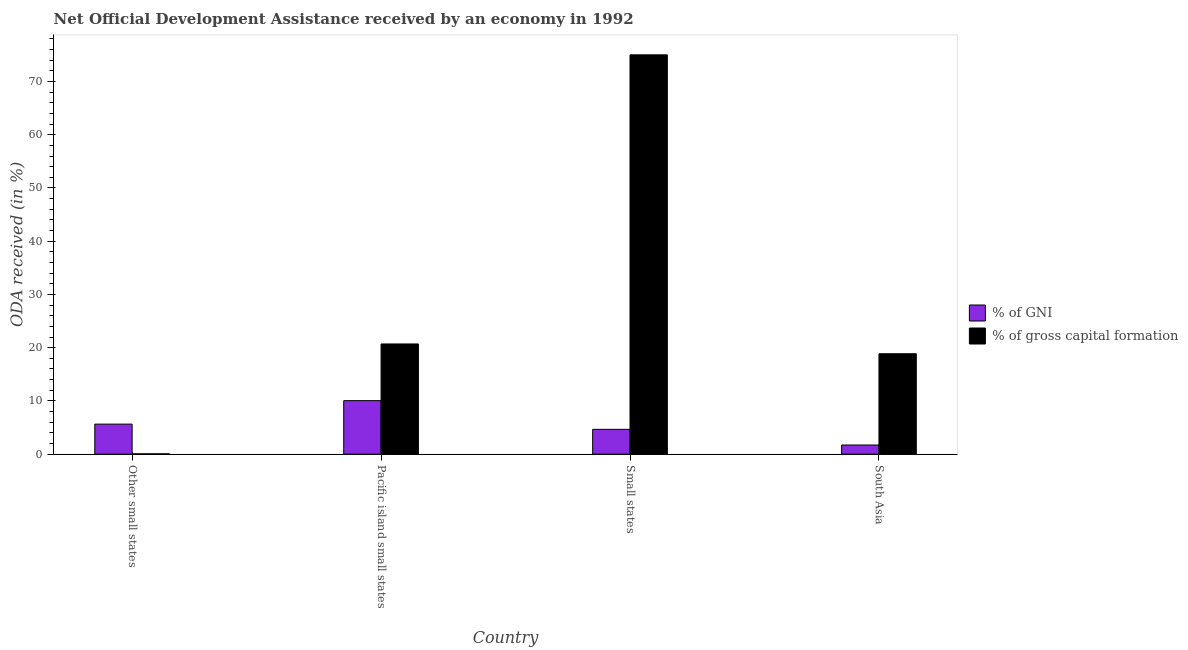How many different coloured bars are there?
Ensure brevity in your answer.  2. How many groups of bars are there?
Offer a terse response. 4. Are the number of bars per tick equal to the number of legend labels?
Keep it short and to the point. Yes. How many bars are there on the 2nd tick from the right?
Your response must be concise. 2. What is the label of the 3rd group of bars from the left?
Provide a succinct answer. Small states. In how many cases, is the number of bars for a given country not equal to the number of legend labels?
Offer a terse response. 0. What is the oda received as percentage of gross capital formation in Small states?
Give a very brief answer. 75. Across all countries, what is the maximum oda received as percentage of gross capital formation?
Offer a very short reply. 75. Across all countries, what is the minimum oda received as percentage of gni?
Give a very brief answer. 1.72. In which country was the oda received as percentage of gross capital formation maximum?
Your response must be concise. Small states. In which country was the oda received as percentage of gni minimum?
Give a very brief answer. South Asia. What is the total oda received as percentage of gross capital formation in the graph?
Give a very brief answer. 114.62. What is the difference between the oda received as percentage of gross capital formation in Other small states and that in Small states?
Give a very brief answer. -74.94. What is the difference between the oda received as percentage of gross capital formation in Small states and the oda received as percentage of gni in Other small states?
Provide a short and direct response. 69.36. What is the average oda received as percentage of gross capital formation per country?
Offer a very short reply. 28.65. What is the difference between the oda received as percentage of gross capital formation and oda received as percentage of gni in South Asia?
Your answer should be very brief. 17.14. What is the ratio of the oda received as percentage of gni in Pacific island small states to that in Small states?
Offer a very short reply. 2.16. Is the oda received as percentage of gni in Other small states less than that in Pacific island small states?
Provide a short and direct response. Yes. Is the difference between the oda received as percentage of gross capital formation in Pacific island small states and South Asia greater than the difference between the oda received as percentage of gni in Pacific island small states and South Asia?
Provide a succinct answer. No. What is the difference between the highest and the second highest oda received as percentage of gni?
Provide a succinct answer. 4.41. What is the difference between the highest and the lowest oda received as percentage of gross capital formation?
Provide a succinct answer. 74.94. In how many countries, is the oda received as percentage of gross capital formation greater than the average oda received as percentage of gross capital formation taken over all countries?
Offer a very short reply. 1. What does the 2nd bar from the left in Pacific island small states represents?
Your answer should be compact. % of gross capital formation. What does the 1st bar from the right in Other small states represents?
Provide a short and direct response. % of gross capital formation. How many countries are there in the graph?
Your response must be concise. 4. What is the title of the graph?
Your response must be concise. Net Official Development Assistance received by an economy in 1992. What is the label or title of the X-axis?
Keep it short and to the point. Country. What is the label or title of the Y-axis?
Your answer should be compact. ODA received (in %). What is the ODA received (in %) of % of GNI in Other small states?
Keep it short and to the point. 5.64. What is the ODA received (in %) of % of gross capital formation in Other small states?
Keep it short and to the point. 0.06. What is the ODA received (in %) of % of GNI in Pacific island small states?
Provide a short and direct response. 10.05. What is the ODA received (in %) of % of gross capital formation in Pacific island small states?
Your answer should be very brief. 20.7. What is the ODA received (in %) of % of GNI in Small states?
Provide a short and direct response. 4.66. What is the ODA received (in %) in % of gross capital formation in Small states?
Your answer should be compact. 75. What is the ODA received (in %) in % of GNI in South Asia?
Your response must be concise. 1.72. What is the ODA received (in %) in % of gross capital formation in South Asia?
Keep it short and to the point. 18.86. Across all countries, what is the maximum ODA received (in %) of % of GNI?
Make the answer very short. 10.05. Across all countries, what is the maximum ODA received (in %) of % of gross capital formation?
Give a very brief answer. 75. Across all countries, what is the minimum ODA received (in %) of % of GNI?
Your answer should be compact. 1.72. Across all countries, what is the minimum ODA received (in %) of % of gross capital formation?
Your answer should be compact. 0.06. What is the total ODA received (in %) of % of GNI in the graph?
Your response must be concise. 22.08. What is the total ODA received (in %) of % of gross capital formation in the graph?
Ensure brevity in your answer.  114.62. What is the difference between the ODA received (in %) of % of GNI in Other small states and that in Pacific island small states?
Make the answer very short. -4.41. What is the difference between the ODA received (in %) in % of gross capital formation in Other small states and that in Pacific island small states?
Keep it short and to the point. -20.64. What is the difference between the ODA received (in %) in % of GNI in Other small states and that in Small states?
Your answer should be very brief. 0.98. What is the difference between the ODA received (in %) of % of gross capital formation in Other small states and that in Small states?
Provide a succinct answer. -74.94. What is the difference between the ODA received (in %) in % of GNI in Other small states and that in South Asia?
Offer a very short reply. 3.92. What is the difference between the ODA received (in %) of % of gross capital formation in Other small states and that in South Asia?
Provide a short and direct response. -18.8. What is the difference between the ODA received (in %) in % of GNI in Pacific island small states and that in Small states?
Keep it short and to the point. 5.39. What is the difference between the ODA received (in %) of % of gross capital formation in Pacific island small states and that in Small states?
Your answer should be compact. -54.3. What is the difference between the ODA received (in %) in % of GNI in Pacific island small states and that in South Asia?
Ensure brevity in your answer.  8.33. What is the difference between the ODA received (in %) in % of gross capital formation in Pacific island small states and that in South Asia?
Your response must be concise. 1.83. What is the difference between the ODA received (in %) of % of GNI in Small states and that in South Asia?
Provide a succinct answer. 2.94. What is the difference between the ODA received (in %) in % of gross capital formation in Small states and that in South Asia?
Your answer should be very brief. 56.14. What is the difference between the ODA received (in %) of % of GNI in Other small states and the ODA received (in %) of % of gross capital formation in Pacific island small states?
Your response must be concise. -15.05. What is the difference between the ODA received (in %) of % of GNI in Other small states and the ODA received (in %) of % of gross capital formation in Small states?
Give a very brief answer. -69.36. What is the difference between the ODA received (in %) in % of GNI in Other small states and the ODA received (in %) in % of gross capital formation in South Asia?
Offer a very short reply. -13.22. What is the difference between the ODA received (in %) of % of GNI in Pacific island small states and the ODA received (in %) of % of gross capital formation in Small states?
Give a very brief answer. -64.95. What is the difference between the ODA received (in %) of % of GNI in Pacific island small states and the ODA received (in %) of % of gross capital formation in South Asia?
Give a very brief answer. -8.81. What is the difference between the ODA received (in %) of % of GNI in Small states and the ODA received (in %) of % of gross capital formation in South Asia?
Provide a succinct answer. -14.2. What is the average ODA received (in %) of % of GNI per country?
Your answer should be very brief. 5.52. What is the average ODA received (in %) in % of gross capital formation per country?
Your response must be concise. 28.65. What is the difference between the ODA received (in %) of % of GNI and ODA received (in %) of % of gross capital formation in Other small states?
Offer a terse response. 5.59. What is the difference between the ODA received (in %) of % of GNI and ODA received (in %) of % of gross capital formation in Pacific island small states?
Your answer should be very brief. -10.64. What is the difference between the ODA received (in %) of % of GNI and ODA received (in %) of % of gross capital formation in Small states?
Make the answer very short. -70.34. What is the difference between the ODA received (in %) in % of GNI and ODA received (in %) in % of gross capital formation in South Asia?
Give a very brief answer. -17.14. What is the ratio of the ODA received (in %) in % of GNI in Other small states to that in Pacific island small states?
Make the answer very short. 0.56. What is the ratio of the ODA received (in %) of % of gross capital formation in Other small states to that in Pacific island small states?
Your answer should be very brief. 0. What is the ratio of the ODA received (in %) of % of GNI in Other small states to that in Small states?
Your answer should be very brief. 1.21. What is the ratio of the ODA received (in %) of % of gross capital formation in Other small states to that in Small states?
Provide a short and direct response. 0. What is the ratio of the ODA received (in %) in % of GNI in Other small states to that in South Asia?
Your answer should be compact. 3.28. What is the ratio of the ODA received (in %) in % of gross capital formation in Other small states to that in South Asia?
Offer a terse response. 0. What is the ratio of the ODA received (in %) of % of GNI in Pacific island small states to that in Small states?
Provide a short and direct response. 2.16. What is the ratio of the ODA received (in %) in % of gross capital formation in Pacific island small states to that in Small states?
Provide a succinct answer. 0.28. What is the ratio of the ODA received (in %) in % of GNI in Pacific island small states to that in South Asia?
Provide a succinct answer. 5.85. What is the ratio of the ODA received (in %) of % of gross capital formation in Pacific island small states to that in South Asia?
Give a very brief answer. 1.1. What is the ratio of the ODA received (in %) in % of GNI in Small states to that in South Asia?
Keep it short and to the point. 2.71. What is the ratio of the ODA received (in %) in % of gross capital formation in Small states to that in South Asia?
Your response must be concise. 3.98. What is the difference between the highest and the second highest ODA received (in %) of % of GNI?
Offer a terse response. 4.41. What is the difference between the highest and the second highest ODA received (in %) of % of gross capital formation?
Provide a succinct answer. 54.3. What is the difference between the highest and the lowest ODA received (in %) of % of GNI?
Provide a short and direct response. 8.33. What is the difference between the highest and the lowest ODA received (in %) in % of gross capital formation?
Your answer should be compact. 74.94. 